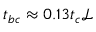<formula> <loc_0><loc_0><loc_500><loc_500>{ t _ { b c } } \approx 0 . 1 3 t _ { c } { \ m a t h s c r { L } }</formula> 